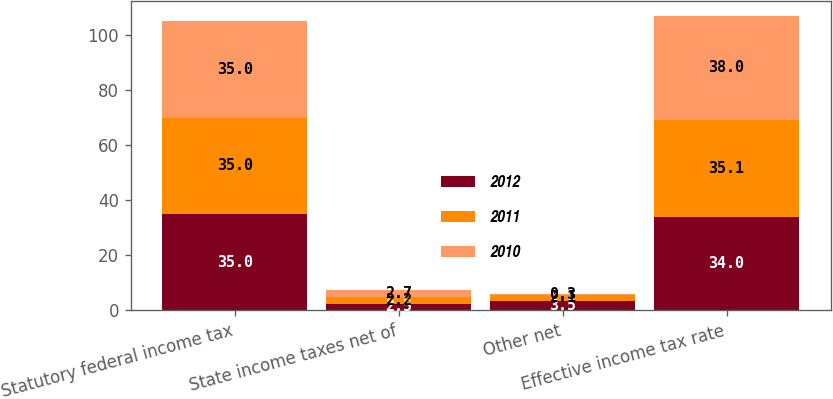Convert chart. <chart><loc_0><loc_0><loc_500><loc_500><stacked_bar_chart><ecel><fcel>Statutory federal income tax<fcel>State income taxes net of<fcel>Other net<fcel>Effective income tax rate<nl><fcel>2012<fcel>35<fcel>2.5<fcel>3.5<fcel>34<nl><fcel>2011<fcel>35<fcel>2.2<fcel>2.1<fcel>35.1<nl><fcel>2010<fcel>35<fcel>2.7<fcel>0.3<fcel>38<nl></chart> 